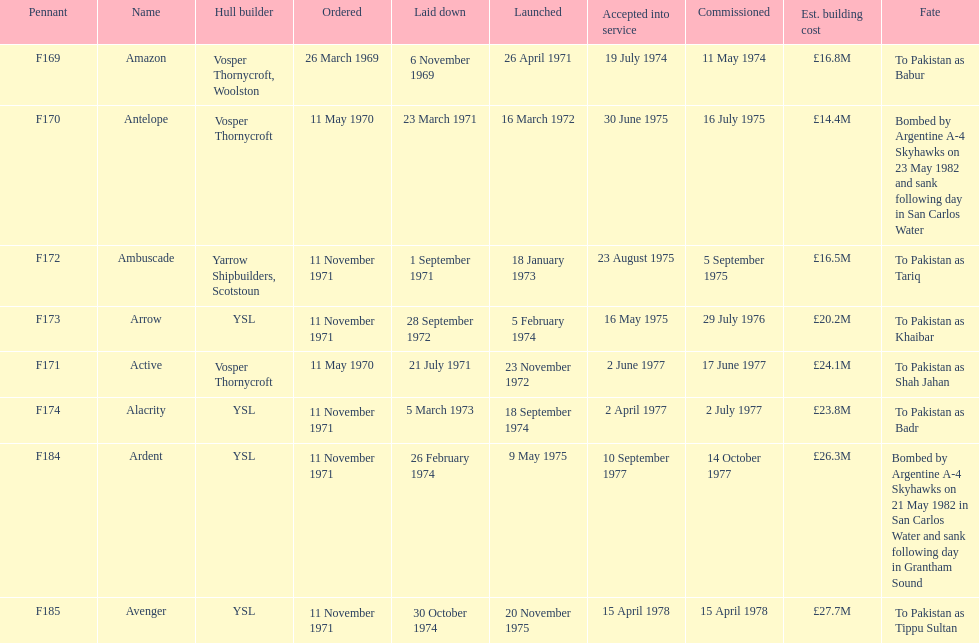What was the preceding vessel? Ambuscade. 